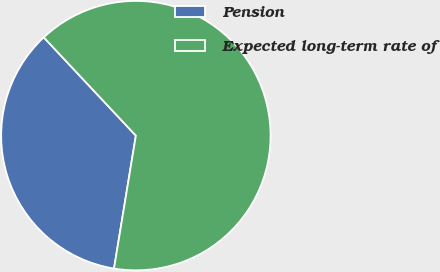Convert chart to OTSL. <chart><loc_0><loc_0><loc_500><loc_500><pie_chart><fcel>Pension<fcel>Expected long-term rate of<nl><fcel>35.42%<fcel>64.58%<nl></chart> 